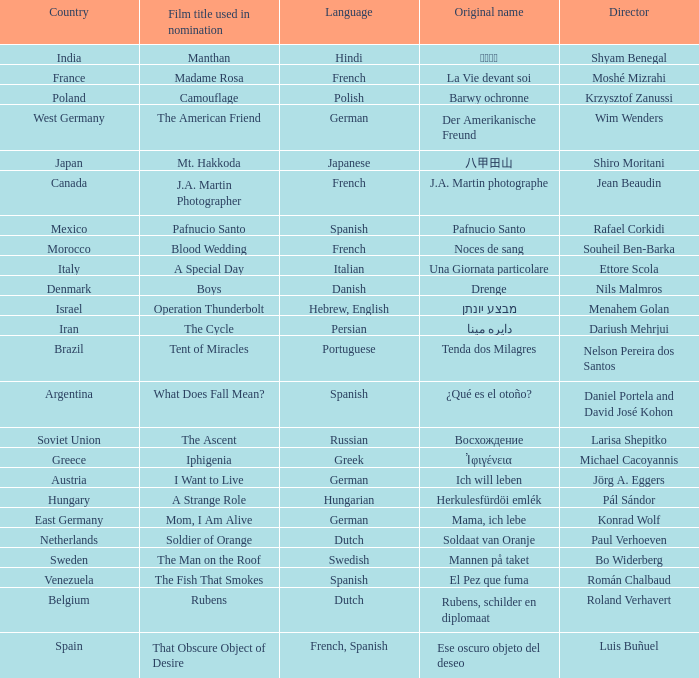What is the title of the German film that is originally called Mama, Ich Lebe? Mom, I Am Alive. Would you mind parsing the complete table? {'header': ['Country', 'Film title used in nomination', 'Language', 'Original name', 'Director'], 'rows': [['India', 'Manthan', 'Hindi', 'मंथन', 'Shyam Benegal'], ['France', 'Madame Rosa', 'French', 'La Vie devant soi', 'Moshé Mizrahi'], ['Poland', 'Camouflage', 'Polish', 'Barwy ochronne', 'Krzysztof Zanussi'], ['West Germany', 'The American Friend', 'German', 'Der Amerikanische Freund', 'Wim Wenders'], ['Japan', 'Mt. Hakkoda', 'Japanese', '八甲田山', 'Shiro Moritani'], ['Canada', 'J.A. Martin Photographer', 'French', 'J.A. Martin photographe', 'Jean Beaudin'], ['Mexico', 'Pafnucio Santo', 'Spanish', 'Pafnucio Santo', 'Rafael Corkidi'], ['Morocco', 'Blood Wedding', 'French', 'Noces de sang', 'Souheil Ben-Barka'], ['Italy', 'A Special Day', 'Italian', 'Una Giornata particolare', 'Ettore Scola'], ['Denmark', 'Boys', 'Danish', 'Drenge', 'Nils Malmros'], ['Israel', 'Operation Thunderbolt', 'Hebrew, English', 'מבצע יונתן', 'Menahem Golan'], ['Iran', 'The Cycle', 'Persian', 'دايره مينا', 'Dariush Mehrjui'], ['Brazil', 'Tent of Miracles', 'Portuguese', 'Tenda dos Milagres', 'Nelson Pereira dos Santos'], ['Argentina', 'What Does Fall Mean?', 'Spanish', '¿Qué es el otoño?', 'Daniel Portela and David José Kohon'], ['Soviet Union', 'The Ascent', 'Russian', 'Восхождение', 'Larisa Shepitko'], ['Greece', 'Iphigenia', 'Greek', 'Ἰφιγένεια', 'Michael Cacoyannis'], ['Austria', 'I Want to Live', 'German', 'Ich will leben', 'Jörg A. Eggers'], ['Hungary', 'A Strange Role', 'Hungarian', 'Herkulesfürdöi emlék', 'Pál Sándor'], ['East Germany', 'Mom, I Am Alive', 'German', 'Mama, ich lebe', 'Konrad Wolf'], ['Netherlands', 'Soldier of Orange', 'Dutch', 'Soldaat van Oranje', 'Paul Verhoeven'], ['Sweden', 'The Man on the Roof', 'Swedish', 'Mannen på taket', 'Bo Widerberg'], ['Venezuela', 'The Fish That Smokes', 'Spanish', 'El Pez que fuma', 'Román Chalbaud'], ['Belgium', 'Rubens', 'Dutch', 'Rubens, schilder en diplomaat', 'Roland Verhavert'], ['Spain', 'That Obscure Object of Desire', 'French, Spanish', 'Ese oscuro objeto del deseo', 'Luis Buñuel']]} 